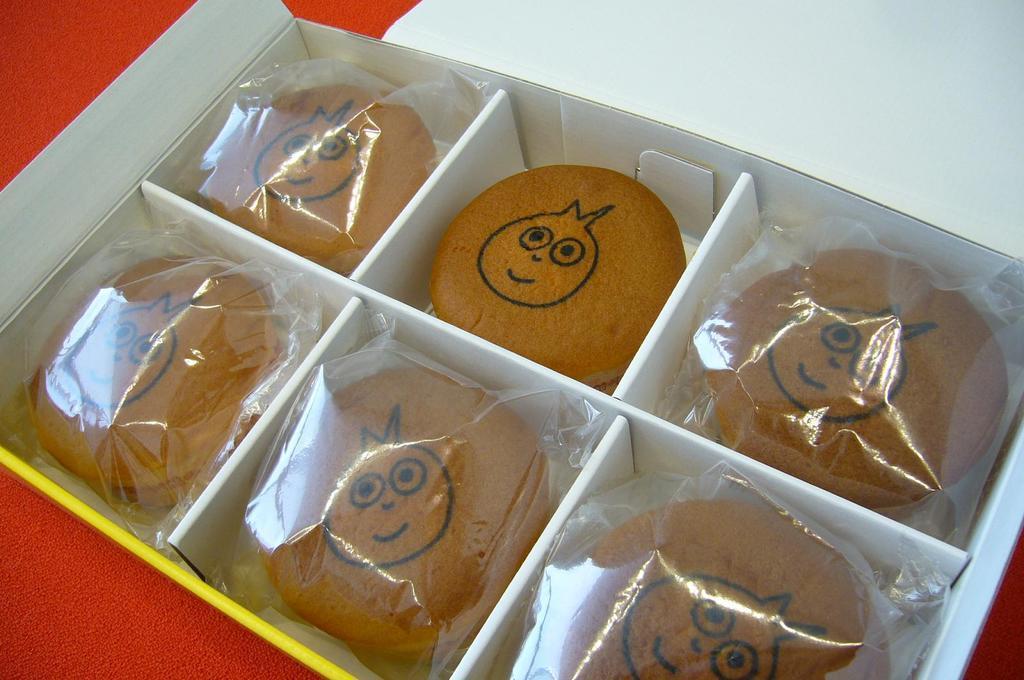Describe this image in one or two sentences. In the image we can see a box. In the box we can see there are six bread buns and five of them are wrapped in a plastic cover. 